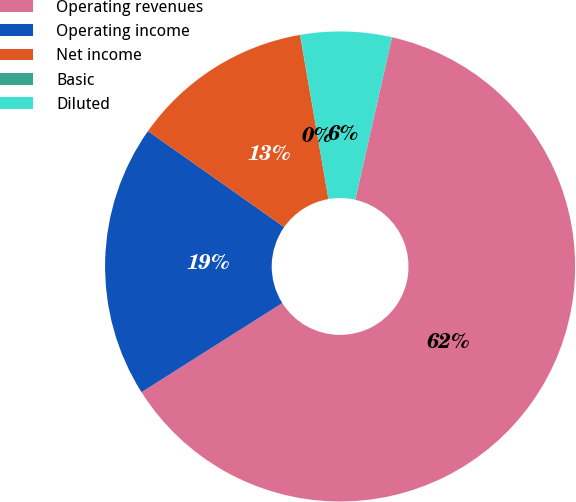<chart> <loc_0><loc_0><loc_500><loc_500><pie_chart><fcel>Operating revenues<fcel>Operating income<fcel>Net income<fcel>Basic<fcel>Diluted<nl><fcel>62.47%<fcel>18.75%<fcel>12.5%<fcel>0.01%<fcel>6.26%<nl></chart> 